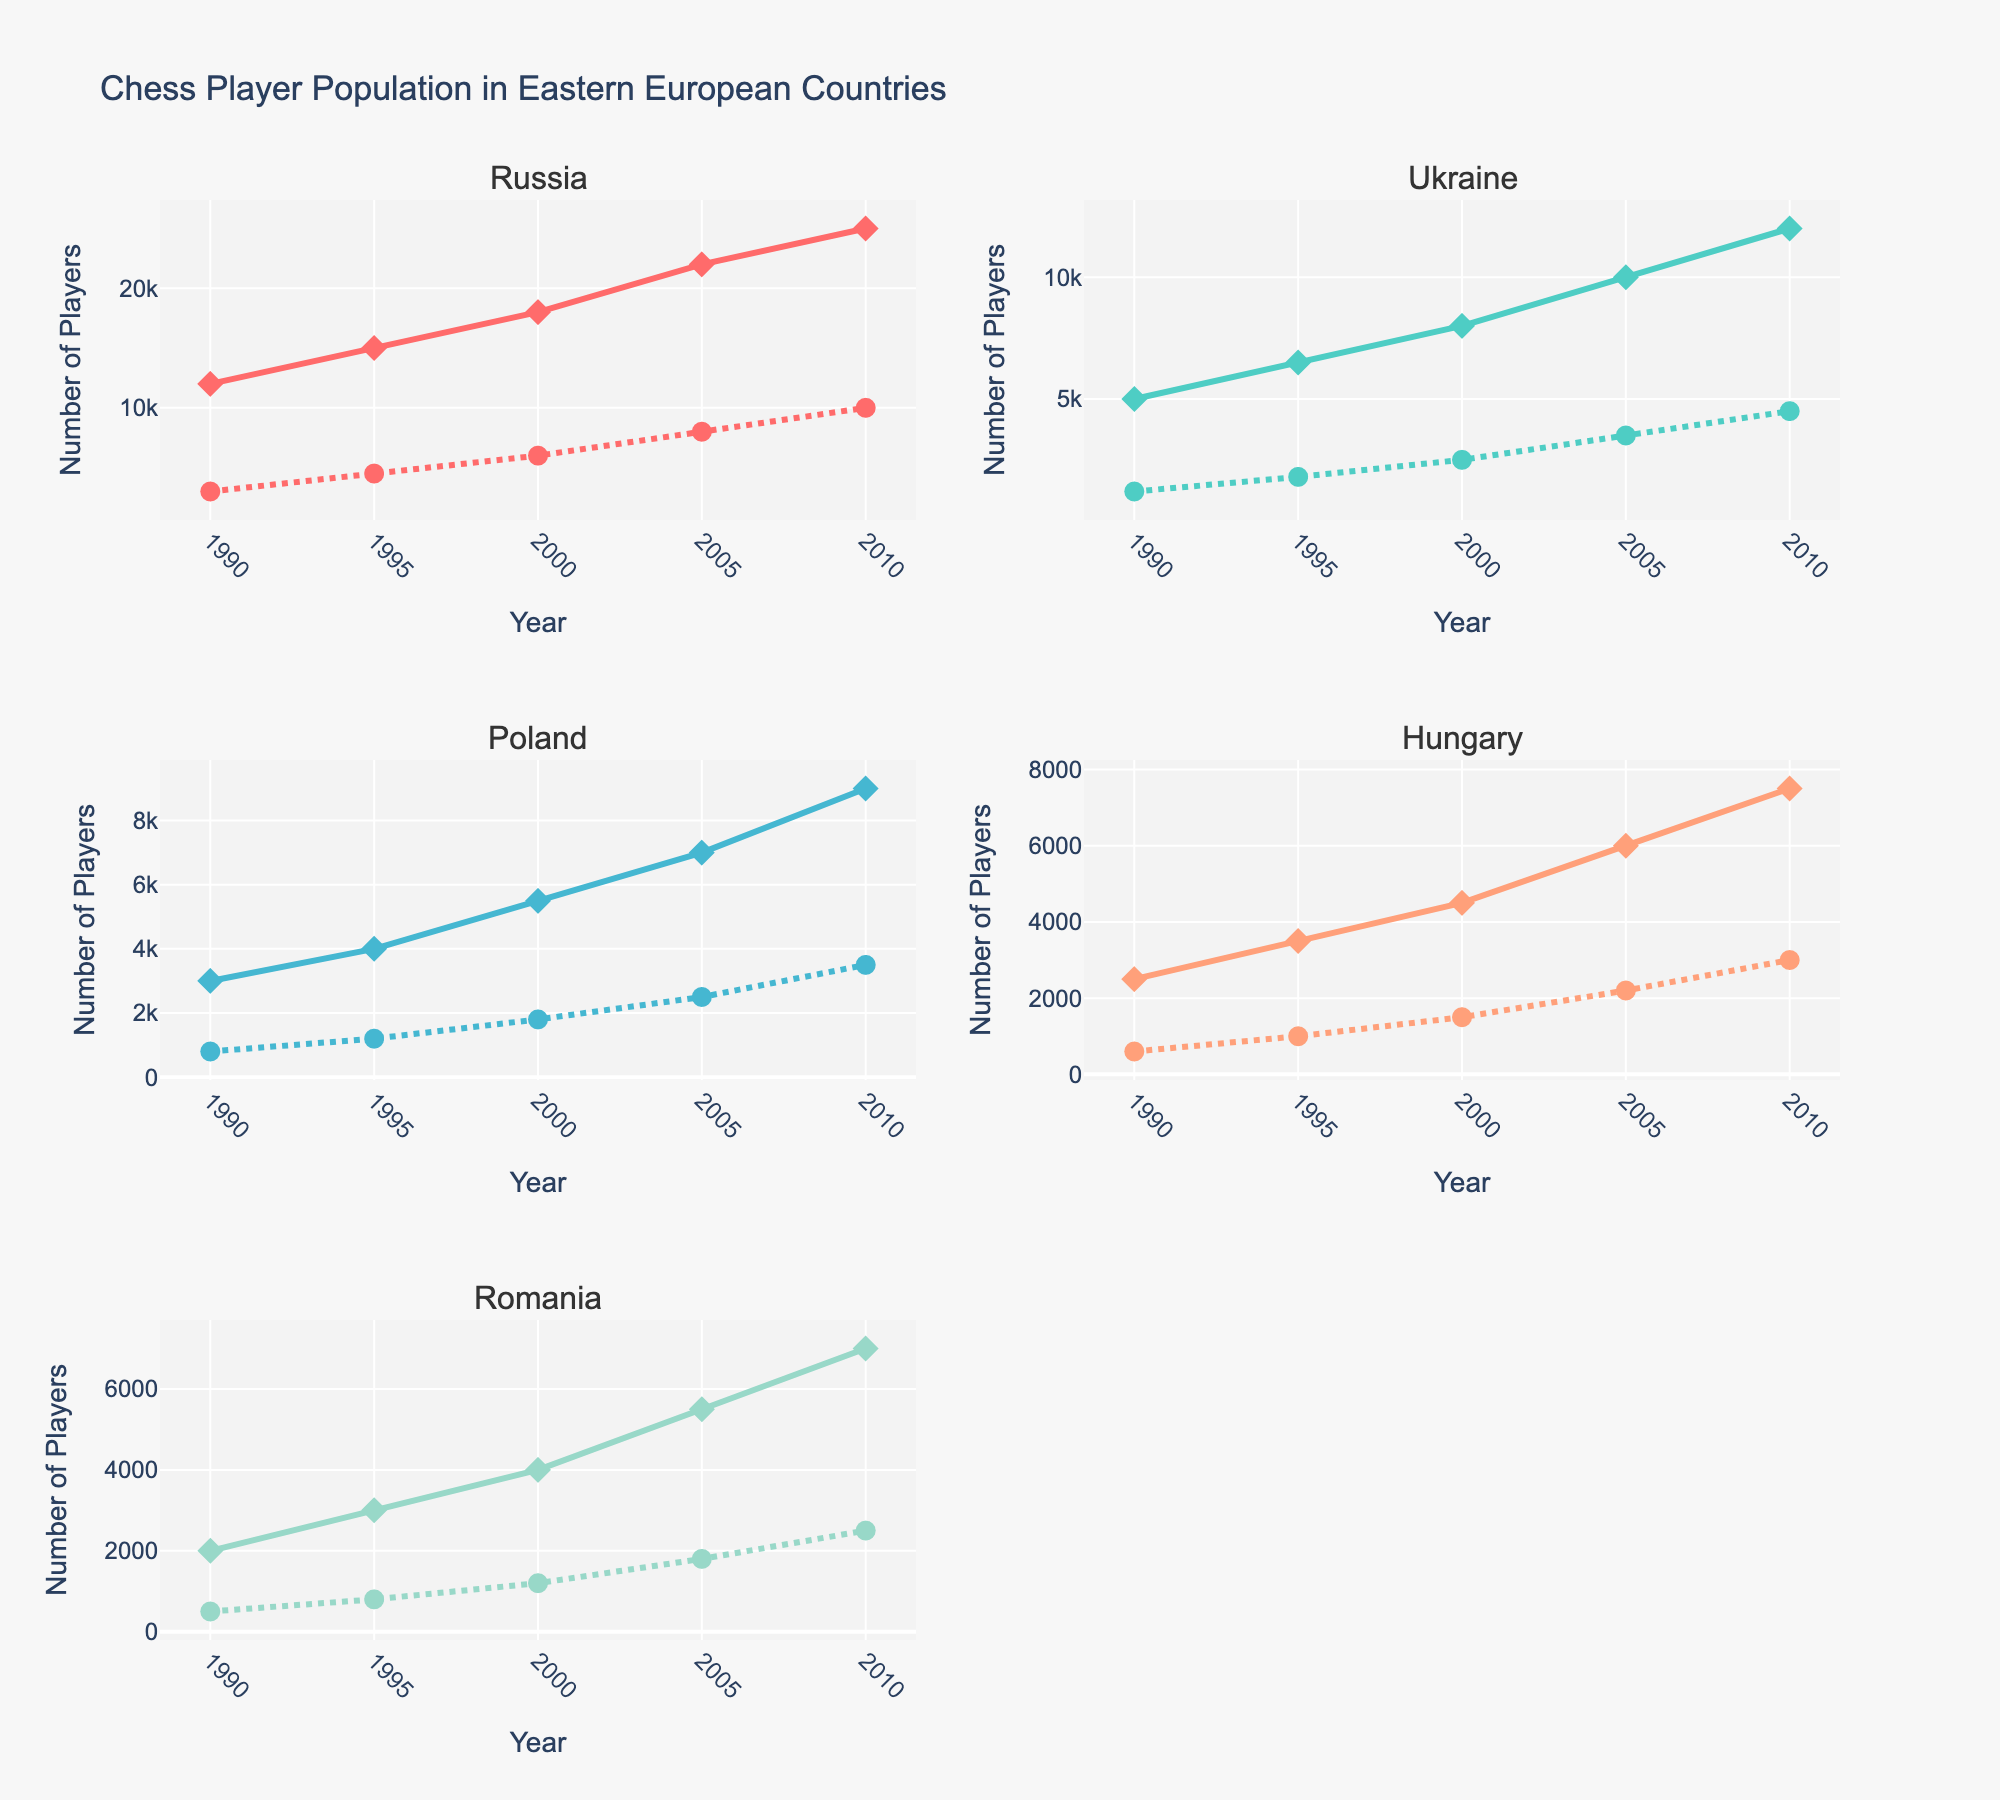What is the title of the figure? The title of the figure is displayed at the top center of the plot. It reads "Chess Player Population in Eastern European Countries".
Answer: Chess Player Population in Eastern European Countries Which country had more female players in 2010, Russia or Ukraine? To answer this, look at the 2010 data points for female players in both Russia and Ukraine. Russia had 10,000 female players, while Ukraine had 4,500 female players.
Answer: Russia In which year did Poland have the highest number of male players, and how many were there? By examining the male players' data across different years for Poland, the highest number is in 2010 with 9,000 male players.
Answer: 2010 with 9,000 male players How many more female players did Hungary have in 2010 compared to 1990? Check the female players' values for Hungary in 2010 and 1990. In 2010, there were 3,000 female players, and in 1990, there were 600. The difference is 3,000 - 600.
Answer: 2,400 more players Which country showed the largest increase in female players from 1990 to 2010? Calculate the increase for each country and compare. Russia: 10,000 - 3,000 = 7,000; Ukraine: 4,500 - 1,200 = 3,300; Poland: 3,500 - 800 = 2,700; Hungary: 3,000 - 600 = 2,400; Romania: 2,500 - 500 = 2,000. Russia had the largest increase.
Answer: Russia Compare the trends in the number of male and female players in Romania from 2005 to 2010. Analyze the lines for male and female players in Romania between 2005 and 2010. Both trends show an increase: male players increased from 5,500 to 7,000, and female players from 1,800 to 2,500.
Answer: Both increased Which country had the smallest female player population in 2000? Check the data points for female players in 2000 across all countries. Romania had the smallest population with 1,200 female players.
Answer: Romania By how much did the number of male players increase in Ukraine from 1990 to 2005? Look at Ukraine's male player data for 1990 (5,000) and 2005 (10,000). Calculate the difference: 10,000 - 5,000.
Answer: 5,000 players What was the trend direction for the number of male players in Poland compared to the number of female players? For Poland, the trend for both male and female players from 1990 to 2010 was upwards, showing an increase in numbers over time for both genders.
Answer: Both increased 